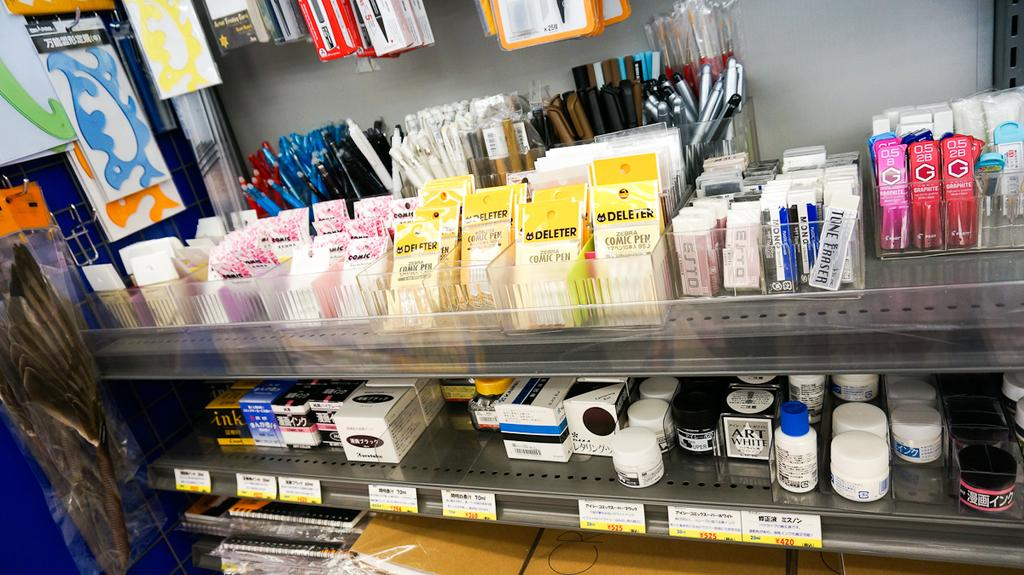Provide a one-sentence caption for the provided image. Packs of Deleter for sale inside of a store. 